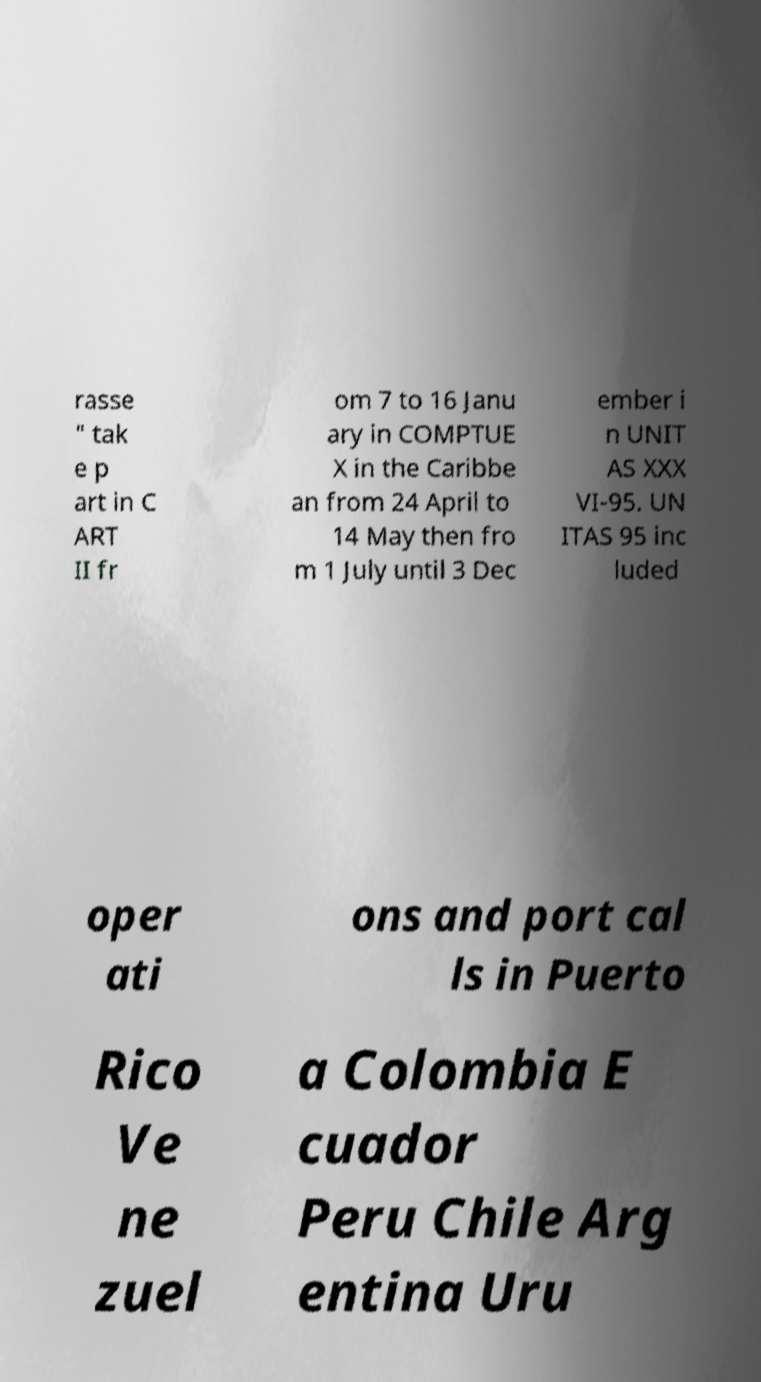For documentation purposes, I need the text within this image transcribed. Could you provide that? rasse " tak e p art in C ART II fr om 7 to 16 Janu ary in COMPTUE X in the Caribbe an from 24 April to 14 May then fro m 1 July until 3 Dec ember i n UNIT AS XXX VI-95. UN ITAS 95 inc luded oper ati ons and port cal ls in Puerto Rico Ve ne zuel a Colombia E cuador Peru Chile Arg entina Uru 